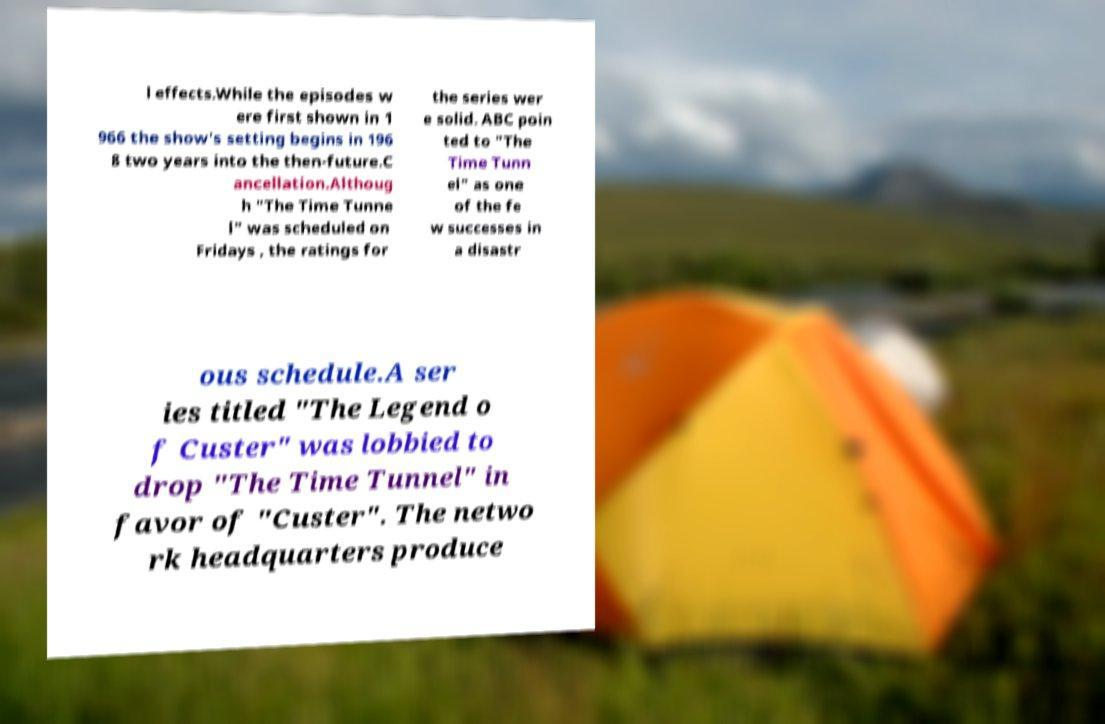Could you assist in decoding the text presented in this image and type it out clearly? l effects.While the episodes w ere first shown in 1 966 the show's setting begins in 196 8 two years into the then-future.C ancellation.Althoug h "The Time Tunne l" was scheduled on Fridays , the ratings for the series wer e solid. ABC poin ted to "The Time Tunn el" as one of the fe w successes in a disastr ous schedule.A ser ies titled "The Legend o f Custer" was lobbied to drop "The Time Tunnel" in favor of "Custer". The netwo rk headquarters produce 